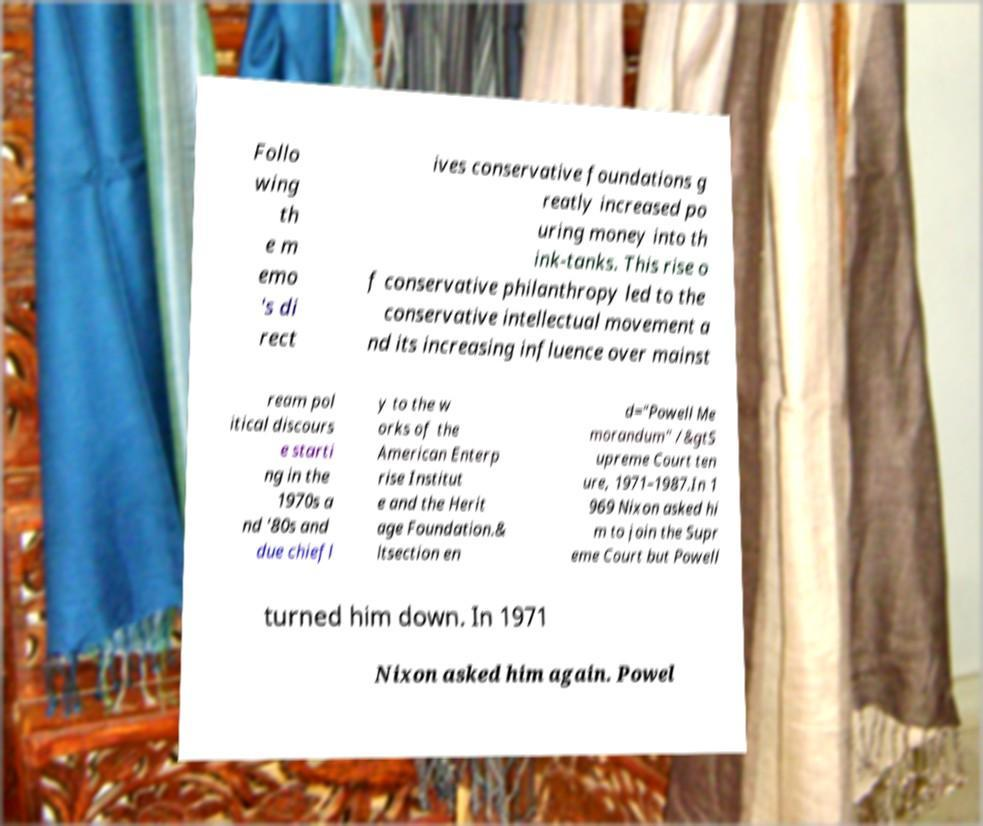Please identify and transcribe the text found in this image. Follo wing th e m emo 's di rect ives conservative foundations g reatly increased po uring money into th ink-tanks. This rise o f conservative philanthropy led to the conservative intellectual movement a nd its increasing influence over mainst ream pol itical discours e starti ng in the 1970s a nd '80s and due chiefl y to the w orks of the American Enterp rise Institut e and the Herit age Foundation.& ltsection en d="Powell Me morandum" /&gtS upreme Court ten ure, 1971–1987.In 1 969 Nixon asked hi m to join the Supr eme Court but Powell turned him down. In 1971 Nixon asked him again. Powel 